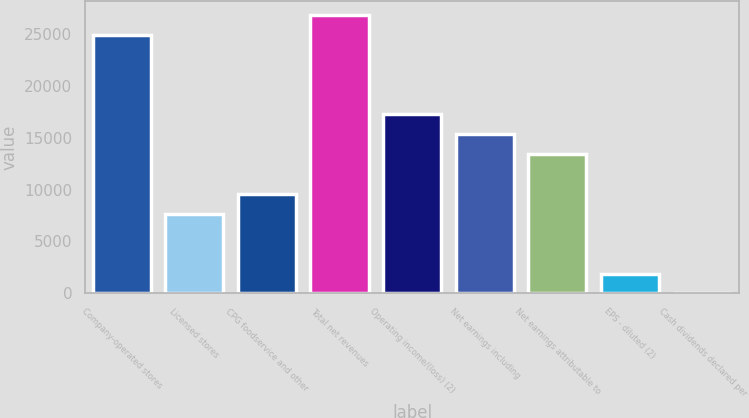<chart> <loc_0><loc_0><loc_500><loc_500><bar_chart><fcel>Company-operated stores<fcel>Licensed stores<fcel>CPG foodservice and other<fcel>Total net revenues<fcel>Operating income/(loss) (2)<fcel>Net earnings including<fcel>Net earnings attributable to<fcel>EPS - diluted (2)<fcel>Cash dividends declared per<nl><fcel>24911.3<fcel>7665.48<fcel>9581.68<fcel>26827.5<fcel>17246.5<fcel>15330.3<fcel>13414.1<fcel>1916.88<fcel>0.68<nl></chart> 